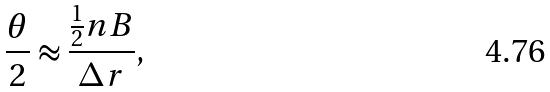<formula> <loc_0><loc_0><loc_500><loc_500>\frac { \theta } { 2 } \approx \frac { \frac { 1 } { 2 } n B } { \Delta r } ,</formula> 